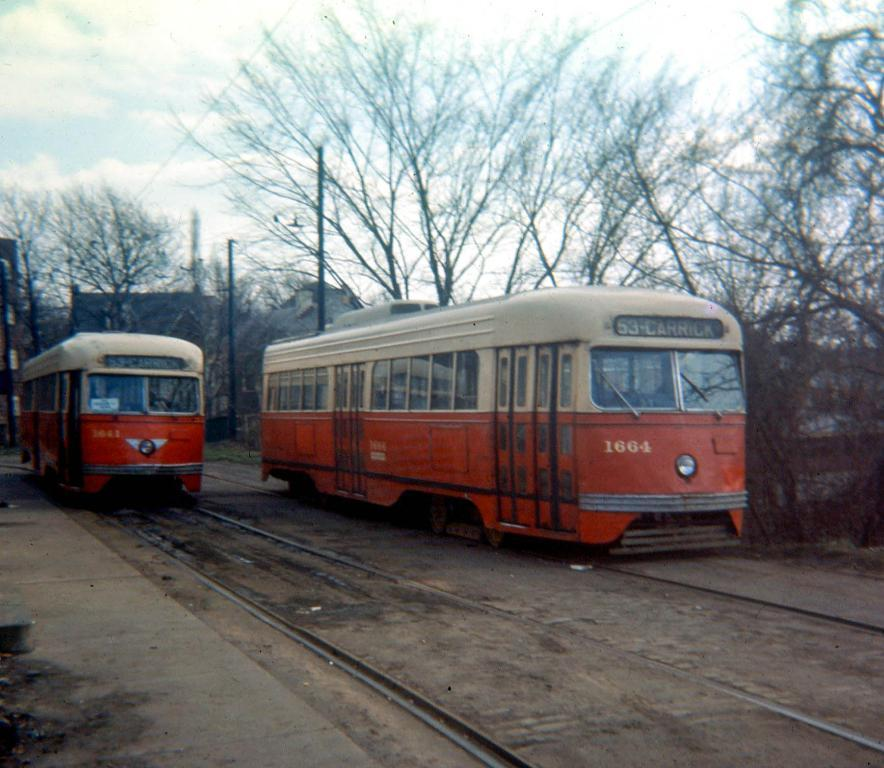What can be seen on both sides of the image? There are trains on both the right and left sides of the image. What is visible in the background of the image? There are trees and poles in the background of the image. What book is your sister reading on the train in the image? There is no sister or book present in the image; it only features trains and background elements. 